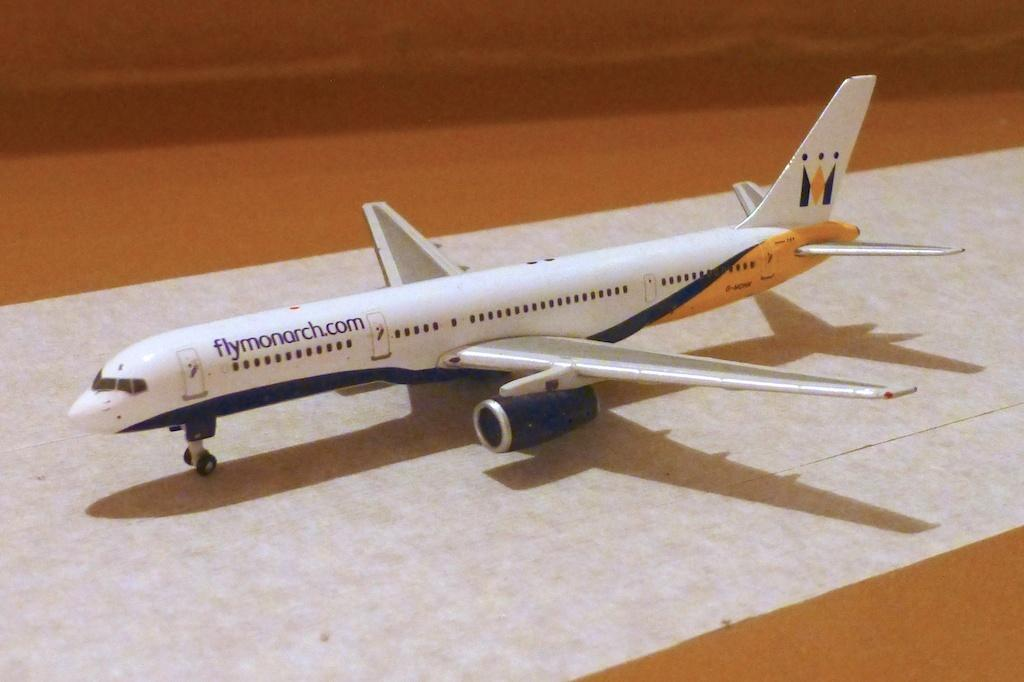What is the main subject of the image? The main subject of the image is an airplane. Where is the airplane located in the image? The airplane is on a runway. How many babies are sitting in the airplane's nest in the image? There is no nest or baby present in the image; it features an airplane on a runway. 